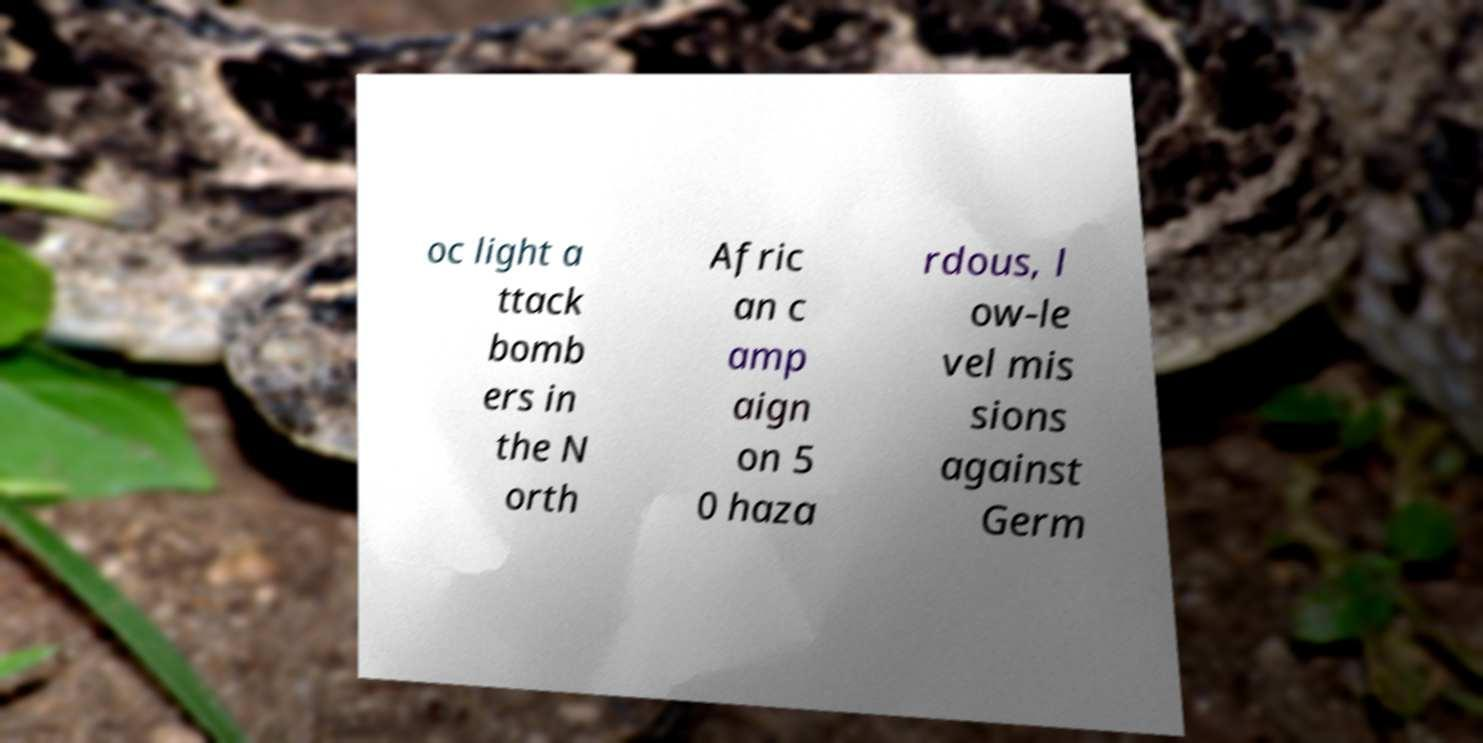There's text embedded in this image that I need extracted. Can you transcribe it verbatim? oc light a ttack bomb ers in the N orth Afric an c amp aign on 5 0 haza rdous, l ow-le vel mis sions against Germ 